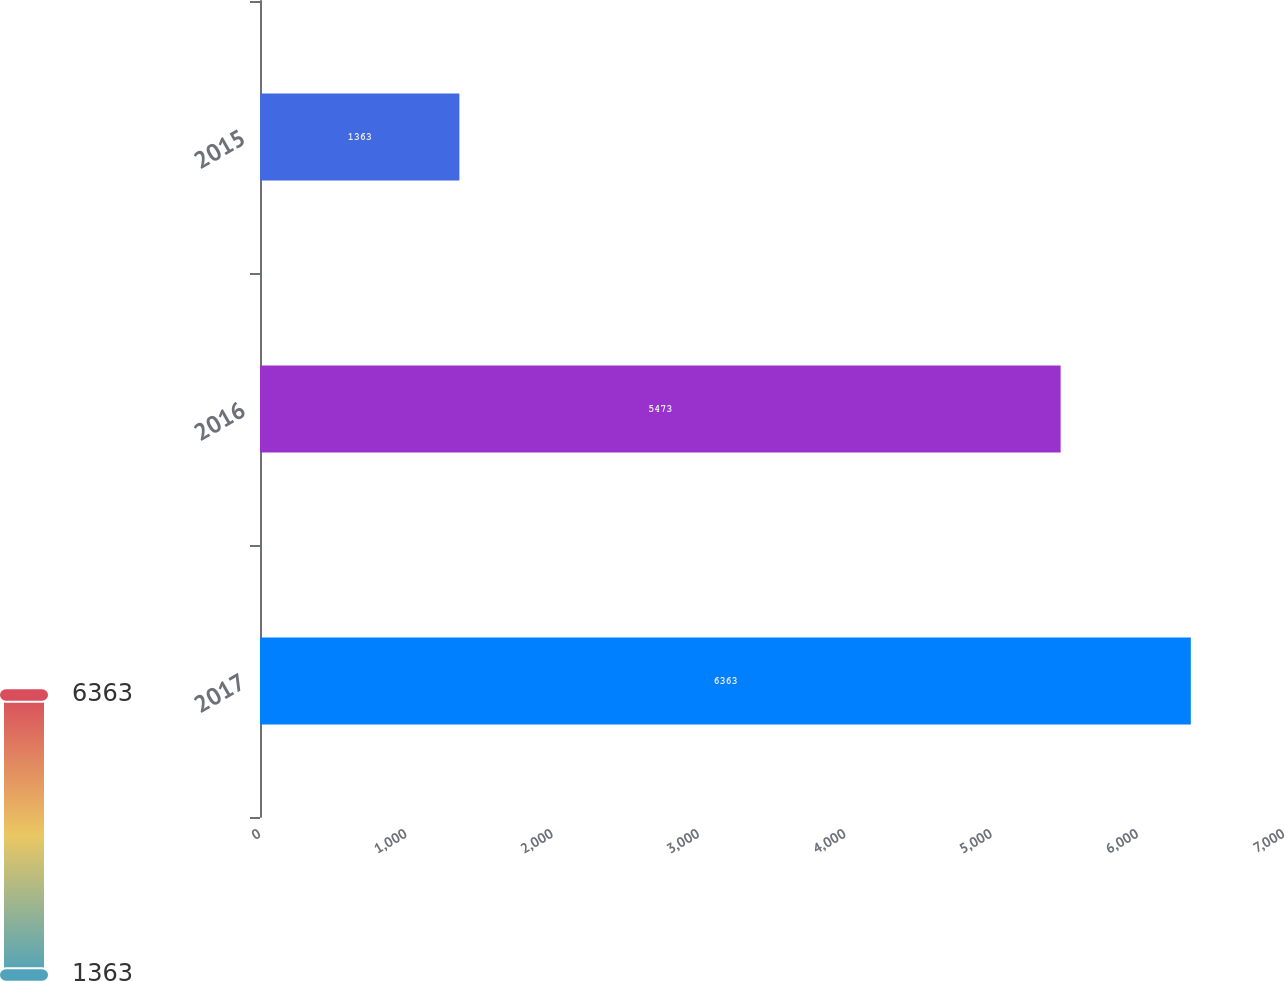<chart> <loc_0><loc_0><loc_500><loc_500><bar_chart><fcel>2017<fcel>2016<fcel>2015<nl><fcel>6363<fcel>5473<fcel>1363<nl></chart> 